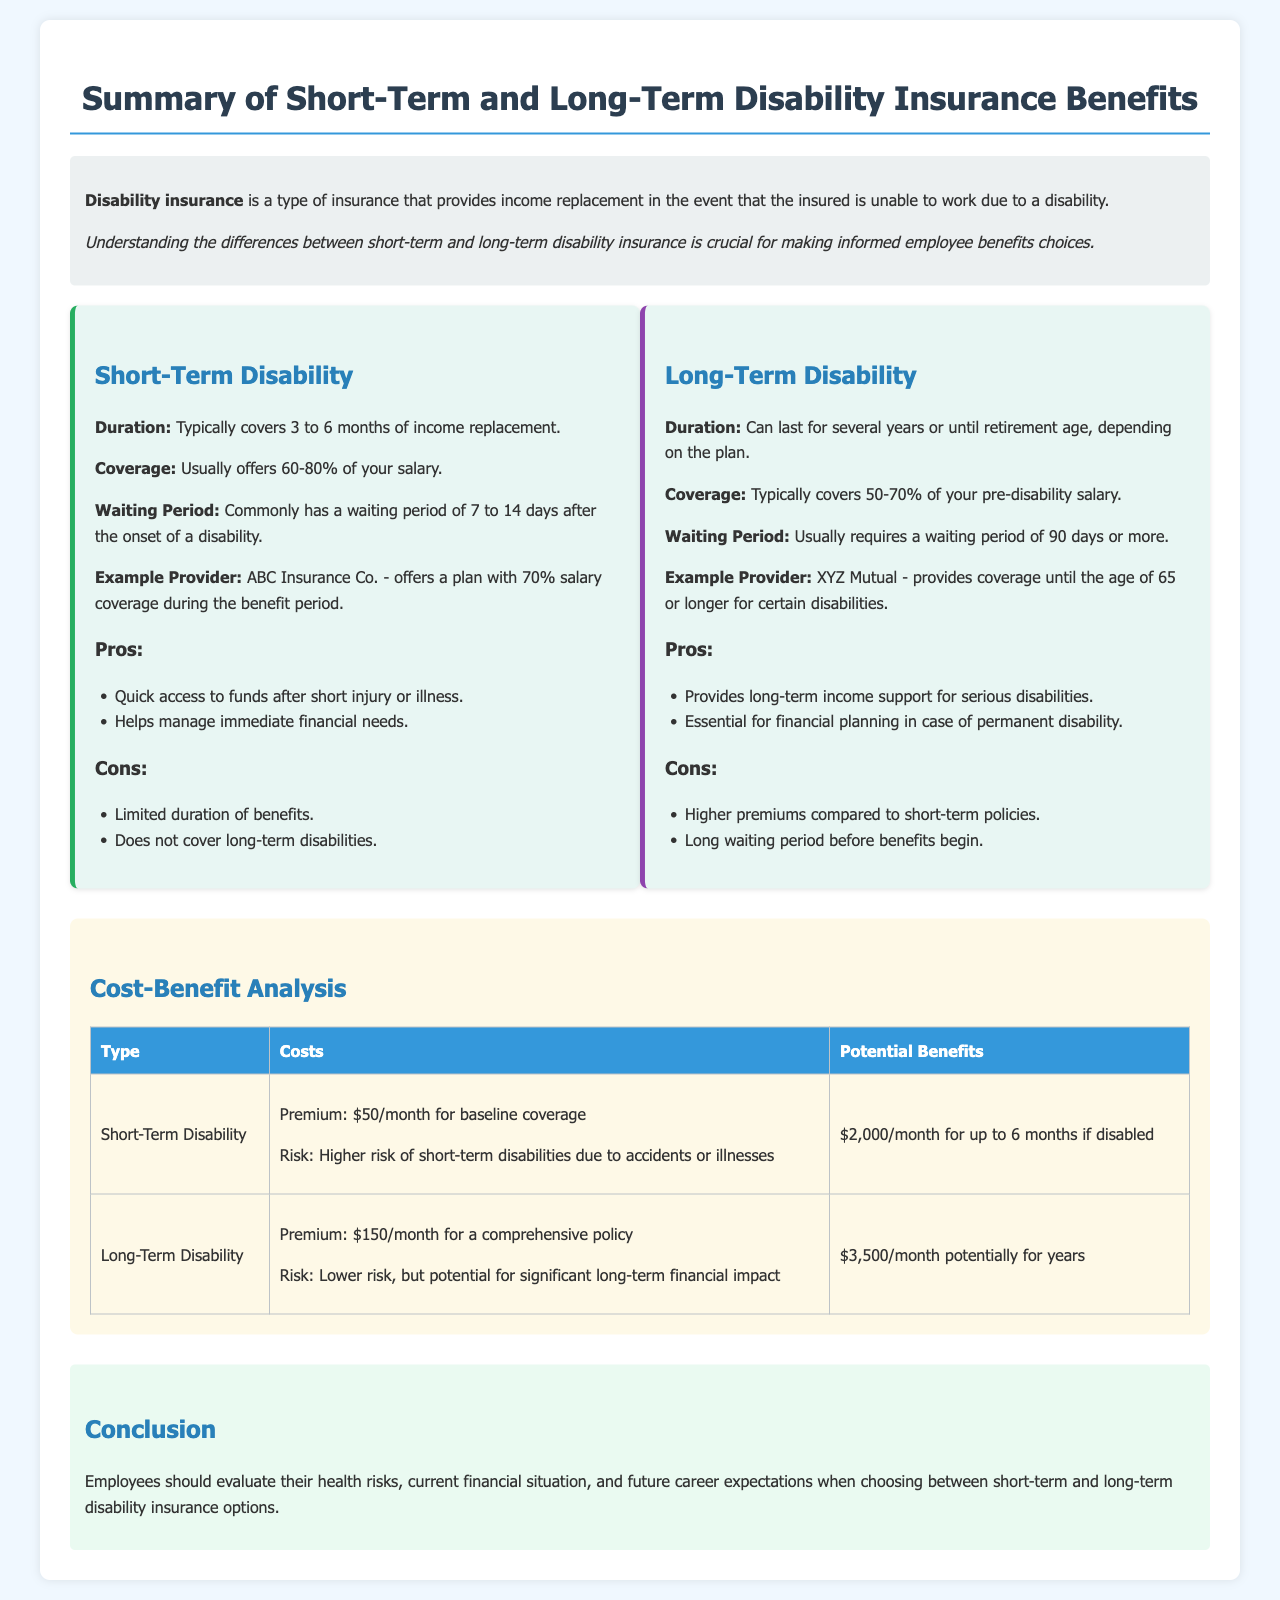What is the coverage percentage for Short-Term Disability? The coverage for Short-Term Disability usually offers 60-80% of your salary.
Answer: 60-80% What is the waiting period for Long-Term Disability? Long-Term Disability usually requires a waiting period of 90 days or more.
Answer: 90 days or more Who is the example provider for Short-Term Disability? The example provider for Short-Term Disability is ABC Insurance Co.
Answer: ABC Insurance Co What is the premium cost for Long-Term Disability? The premium for Long-Term Disability is $150/month for a comprehensive policy.
Answer: $150/month What is the maximum benefit amount for Short-Term Disability? The maximum benefit amount for Short-Term Disability is $2,000/month for up to 6 months if disabled.
Answer: $2,000/month Why is Long-Term Disability essential for financial planning? Long-Term Disability provides long-term income support for serious disabilities.
Answer: Long-term income support What should employees evaluate when choosing between disability insurance options? Employees should evaluate their health risks, current financial situation, and future career expectations.
Answer: Health risks, financial situation, career expectations How long does Short-Term Disability typically cover income replacement? Short-Term Disability typically covers 3 to 6 months of income replacement.
Answer: 3 to 6 months 